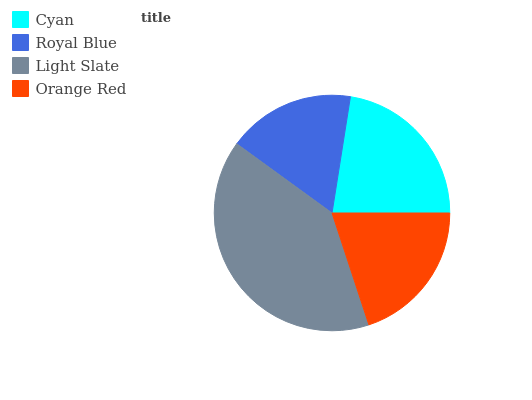Is Royal Blue the minimum?
Answer yes or no. Yes. Is Light Slate the maximum?
Answer yes or no. Yes. Is Light Slate the minimum?
Answer yes or no. No. Is Royal Blue the maximum?
Answer yes or no. No. Is Light Slate greater than Royal Blue?
Answer yes or no. Yes. Is Royal Blue less than Light Slate?
Answer yes or no. Yes. Is Royal Blue greater than Light Slate?
Answer yes or no. No. Is Light Slate less than Royal Blue?
Answer yes or no. No. Is Cyan the high median?
Answer yes or no. Yes. Is Orange Red the low median?
Answer yes or no. Yes. Is Light Slate the high median?
Answer yes or no. No. Is Light Slate the low median?
Answer yes or no. No. 